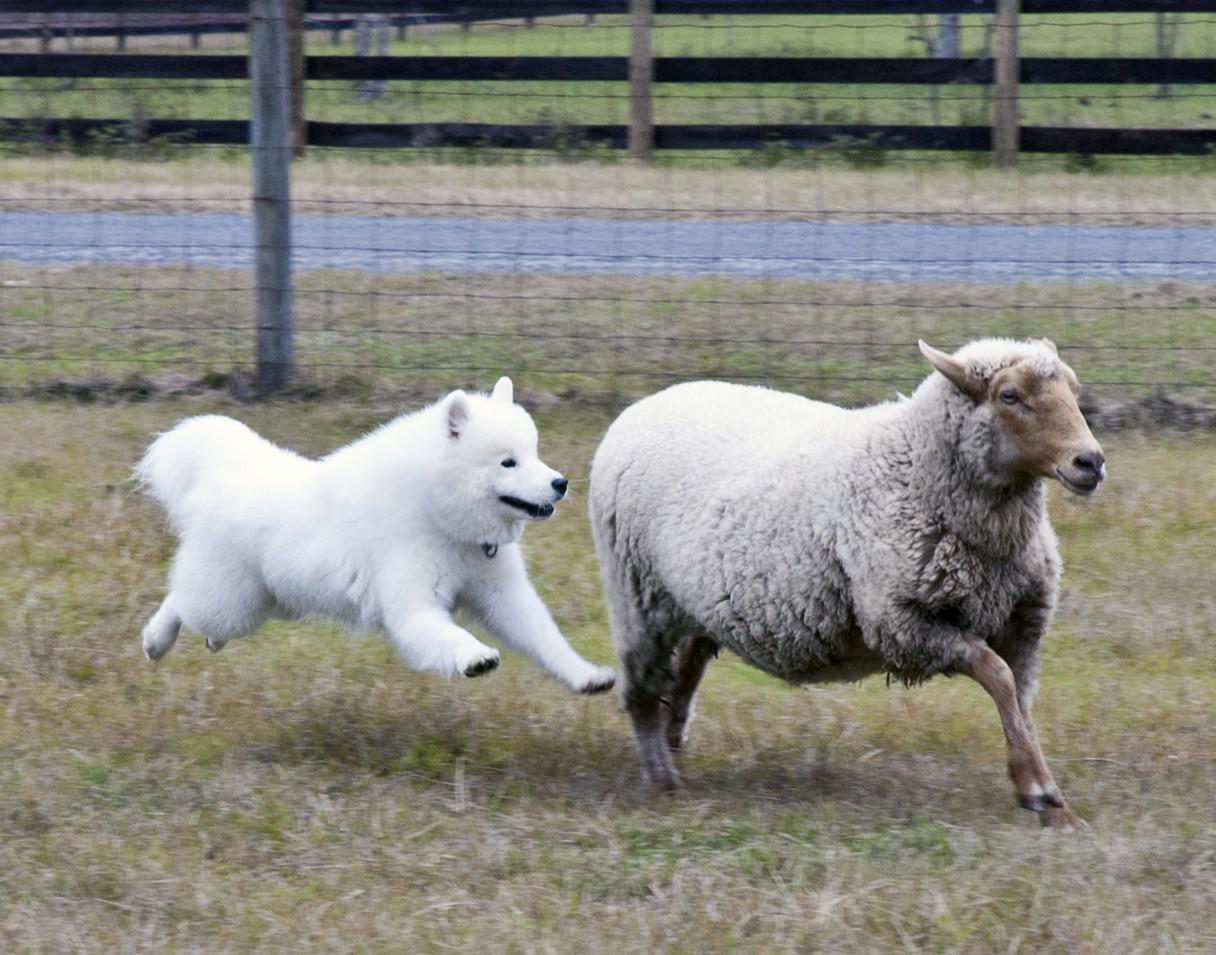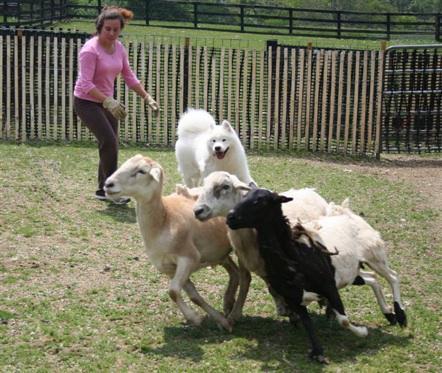The first image is the image on the left, the second image is the image on the right. Evaluate the accuracy of this statement regarding the images: "There is a woman standing and facing right.". Is it true? Answer yes or no. Yes. 